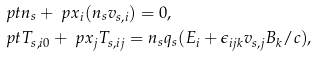<formula> <loc_0><loc_0><loc_500><loc_500>& \ p { t } n _ { s } + \ p { x _ { i } } ( n _ { s } v _ { s , i } ) = 0 , \\ & \ p { t } T _ { s , i 0 } + \ p { x _ { j } } T _ { s , i j } = n _ { s } q _ { s } ( E _ { i } + \epsilon _ { i j k } v _ { s , j } B _ { k } / c ) ,</formula> 